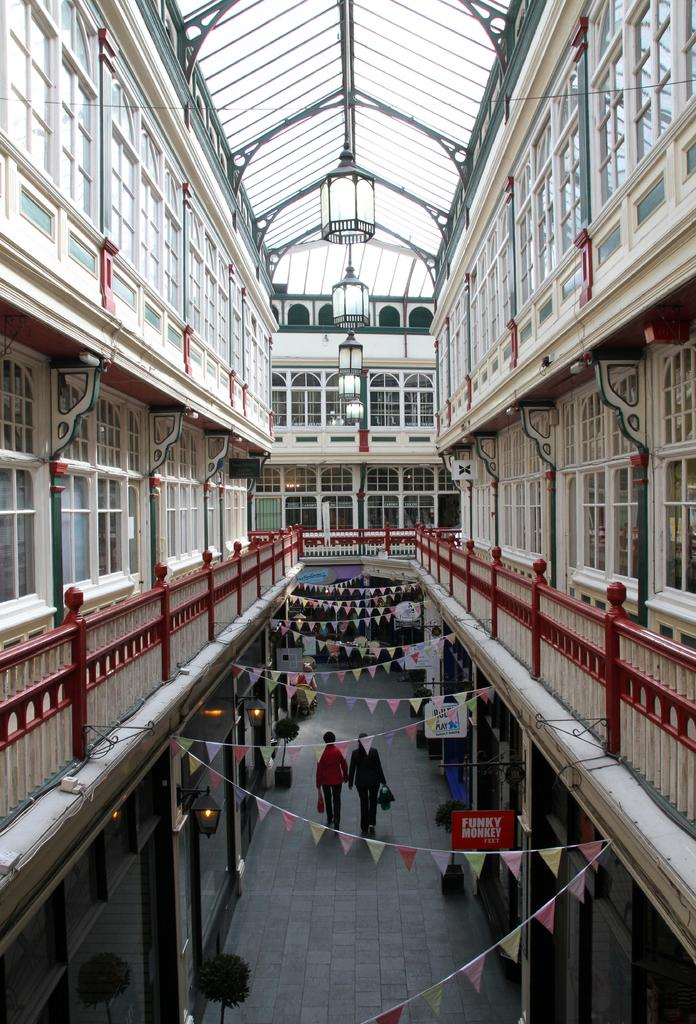What type of structure is shown in the image? There is a building in the image. What can be seen hanging from the top of the building? Electric lights are hanged from the top in the image. What feature is present to provide safety or support? Railings are present in the image. Are there any plants visible in the image? Yes, houseplants are visible in the image. What additional elements are present for aesthetic purposes? Decorations are present in the image. Can you describe the people in the image? There are persons standing on the floor in the image. Where is the shelf located in the image? There is no shelf present in the image. How many babies are crawling on the floor in the image? There are no babies present in the image. 